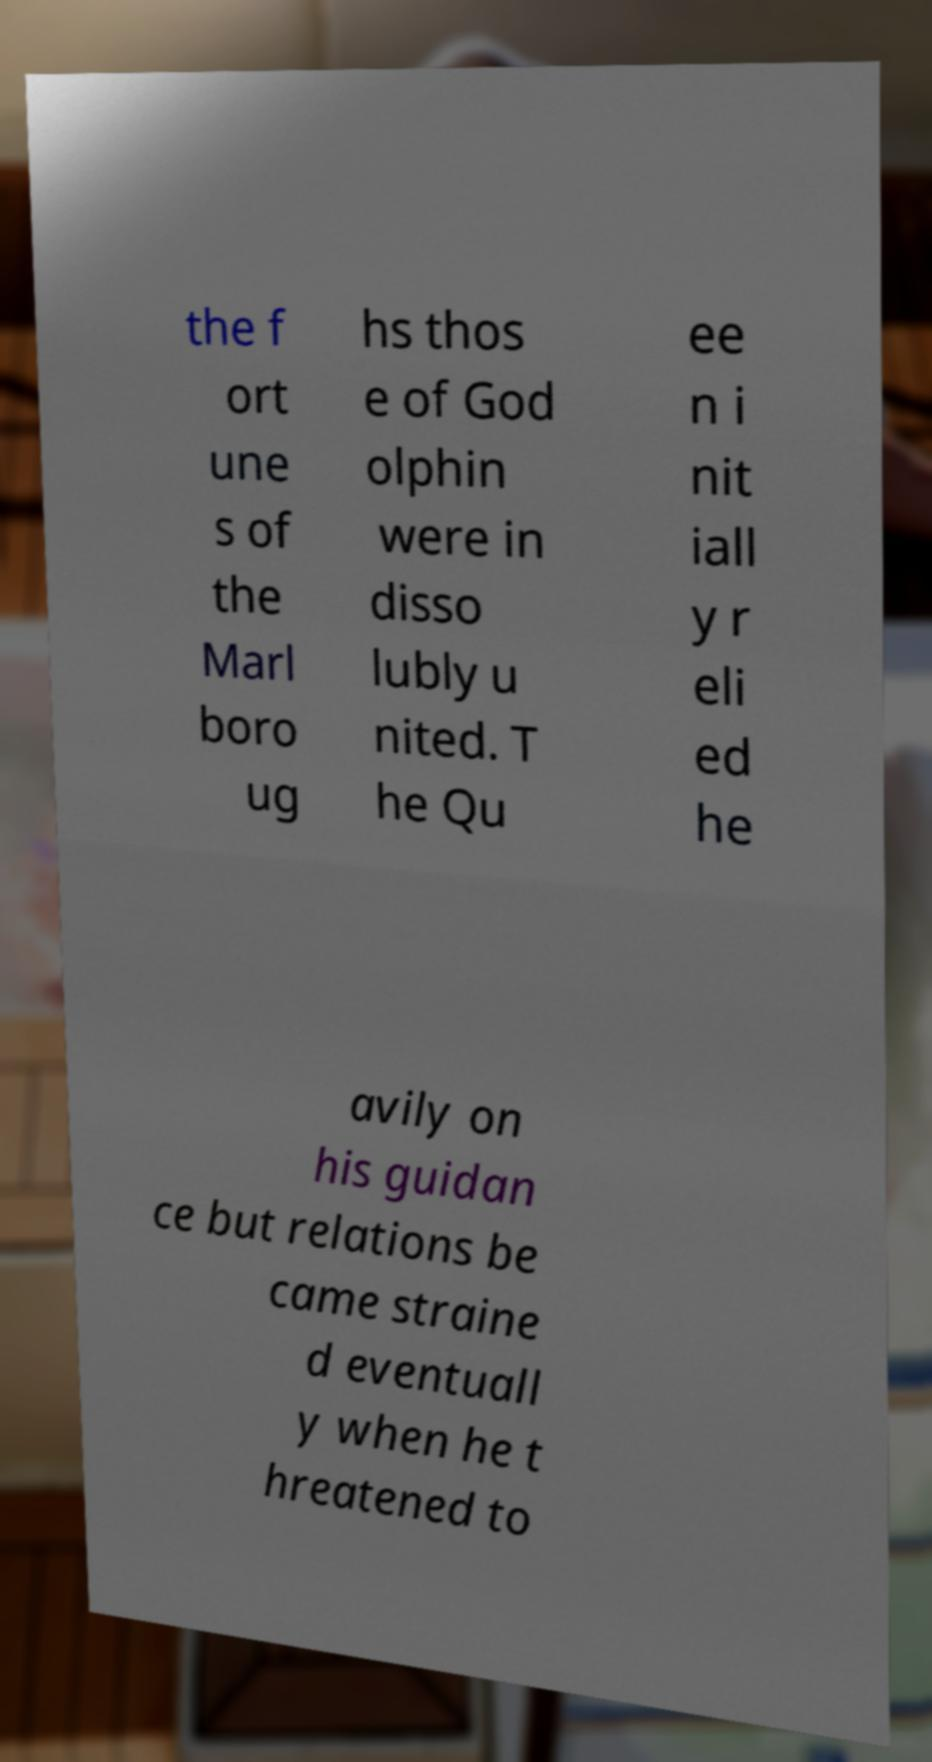Could you assist in decoding the text presented in this image and type it out clearly? the f ort une s of the Marl boro ug hs thos e of God olphin were in disso lubly u nited. T he Qu ee n i nit iall y r eli ed he avily on his guidan ce but relations be came straine d eventuall y when he t hreatened to 